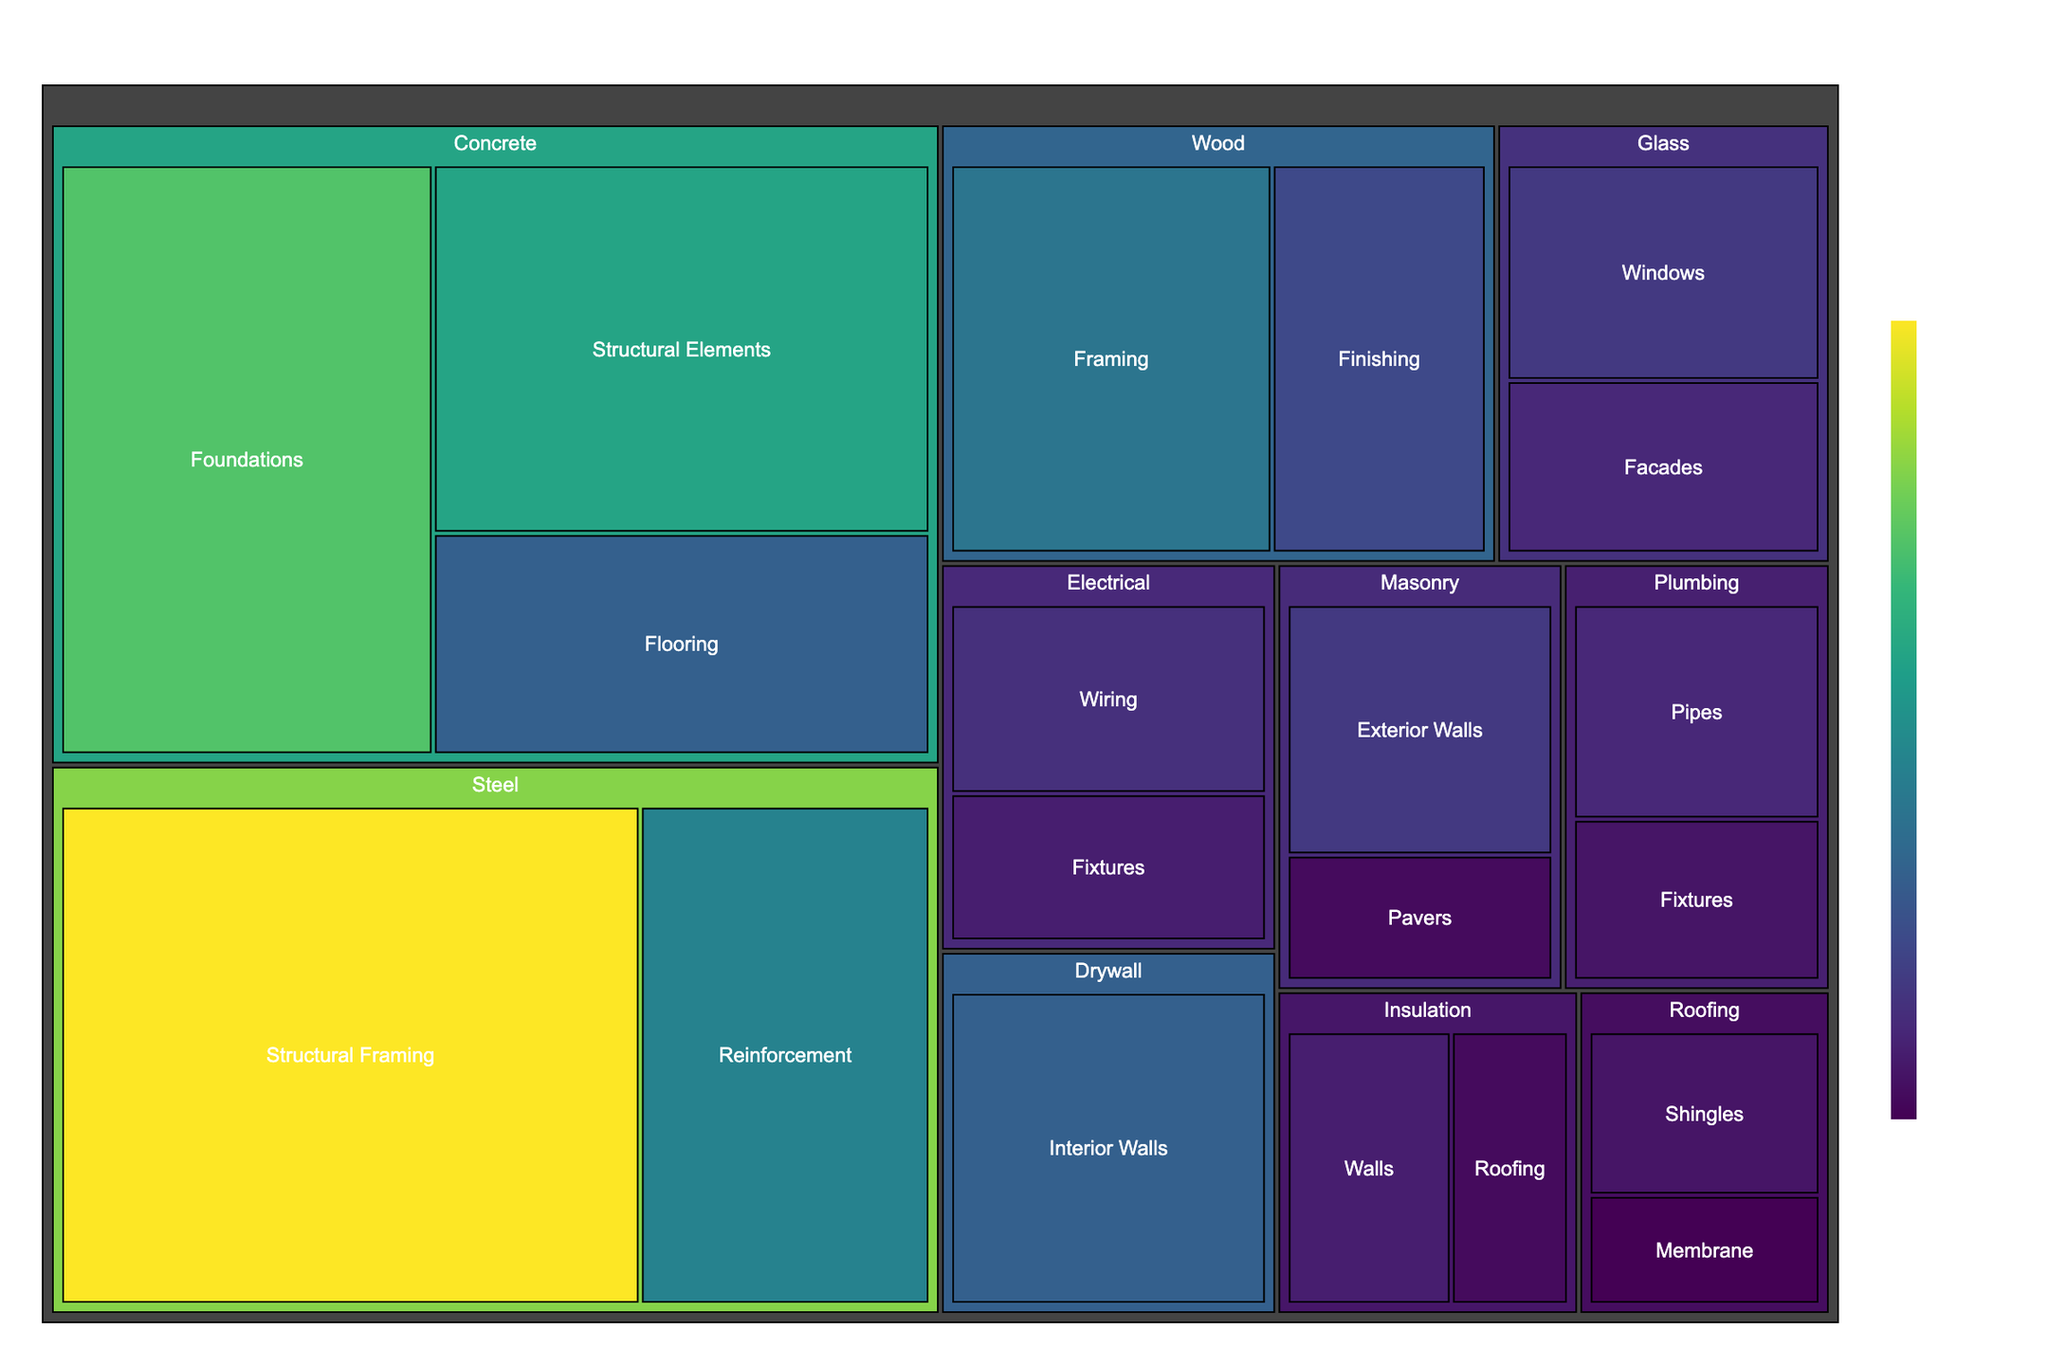What is the title of the treemap? The title is usually displayed at the top center of a chart in larger font size. It provides a concise description of what the chart represents. In this case, the title reads "Construction Material Usage Distribution."
Answer: Construction Material Usage Distribution What category uses the most material? To determine the category that uses the most material, we look for the largest block in the treemap. The size of the blocks is proportional to the value associated with each category. The largest block corresponds to "Steel".
Answer: Steel Which subcategory within 'Concrete' has the highest value? Within the 'Concrete' category, we look for the subcategory with the largest block. Among 'Foundations', 'Structural Elements', and 'Flooring', the 'Foundations' subcategory has the highest value.
Answer: Foundations How much more material does 'Steel' use for 'Structural Framing' than for 'Reinforcement'? To find out how much more material "Steel" uses for "Structural Framing" compared to "Reinforcement," we subtract the value for 'Reinforcement' from 'Structural Framing'. 'Structural Framing' uses 40 units and 'Reinforcement' uses 20 units. 40 - 20 = 20.
Answer: 20 What is the combined value of material usage for 'Wood'? To find the combined value of material usage for 'Wood', we sum the values of its subcategories. 'Framing' has 18 units and 'Finishing' has 12 units. 18 + 12 = 30.
Answer: 30 Which subcategory within 'Plumbing' uses the least material? Within 'Plumbing', we compare the subcategories 'Pipes' and 'Fixtures'. 'Fixtures' uses 6 units and 'Pipes' uses 8 units, so 'Fixtures' uses the least.
Answer: Fixtures Is the value of material usage for 'Electrical' higher for 'Wiring' or 'Fixtures'? By comparing the size of the blocks for 'Wiring' and 'Fixtures' under 'Electrical', 'Wiring' has a higher value with 9 units compared to 'Fixtures' which has 7 units.
Answer: Wiring What is the total value of material usage for categories that start with the letter 'R'? Categories starting with 'R' are 'Roofing'. Summing up the values of its subcategories 'Shingles' (6) and 'Membrane' (4). 6 + 4 = 10.
Answer: 10 Which category has the closest combined value to 'Concrete'? Calculating the combined values, 'Concrete' has 70 units (30 + 25 + 15). The closest combined value would be 'Steel' with 60 units (40 + 20).
Answer: Steel What is the difference in usage value between 'Masonry' and 'Insulation'? Adding subcategory values gives 'Masonry' a total of 15 units (10 + 5), and 'Insulation' a total of 12 units (7 + 5). The difference is 15 - 12 = 3.
Answer: 3 